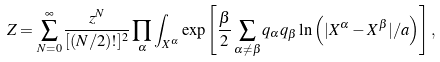Convert formula to latex. <formula><loc_0><loc_0><loc_500><loc_500>Z = \sum _ { N = 0 } ^ { \infty } \frac { z ^ { N } } { [ ( N / 2 ) ! ] ^ { 2 } } \prod _ { \alpha } \int _ { { X } ^ { \alpha } } \exp \left [ \frac { \beta } { 2 } \sum _ { \alpha \neq \beta } q _ { \alpha } q _ { \beta } \ln \left ( | { X } ^ { \alpha } - { X } ^ { \beta } | / a \right ) \right ] ,</formula> 